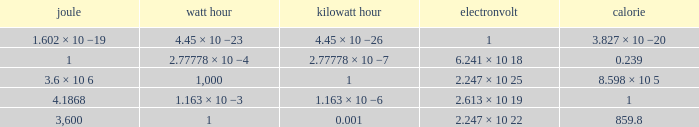How many electronvolts is 3,600 joules? 2.247 × 10 22. 